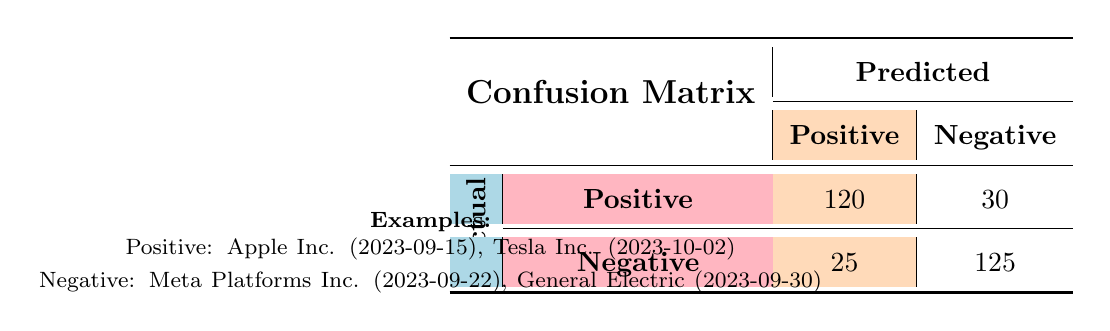What is the number of true positives in the model? The confusion matrix lists the actual positive that were predicted as positive, which is 120.
Answer: 120 How many false negatives are identified in the model? The confusion matrix indicates that there are 30 actual positives that were predicted as negative.
Answer: 30 What percentage of predictions were true negatives? To find this, we take the true negatives (125) and divide by the total actual negatives (25 + 125). The calculation is 125 / 150 = 0.8333, which is approximately 83.33%.
Answer: 83.33% What is the total number of actual positive predictions? The sum of actual positives is calculated as true positives (120) plus false negatives (30). Therefore, 120 + 30 equals 150.
Answer: 150 Is the number of false positives greater than the number of false negatives? The matrix shows there are 25 false positives and 30 false negatives; since 25 is not greater than 30, the answer is no.
Answer: No What is the total number of predictions made by the model? We can calculate the total predictions by summing all values in the confusion matrix: 120 (true positives) + 30 (false negatives) + 25 (false positives) + 125 (true negatives) equals 300.
Answer: 300 How many more true negatives are there than false positives? The difference can be calculated by subtracting false positives (25) from true negatives (125). Thus, 125 - 25 equals 100.
Answer: 100 What is the ratio of true positives to total predictions? First, we find the total number of predictions (300) and the number of true positives (120). The ratio is 120 divided by 300, which simplifies to 0.4 or 40%.
Answer: 0.4 or 40% Are there more actual negative predictions than actual positive ones? The table shows there are 125 true negatives and 150 true positives. Since 125 is less than 150, the answer is no.
Answer: No 